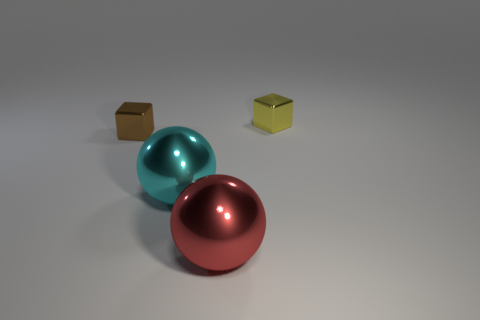Is there any other thing that is the same size as the cyan shiny thing?
Ensure brevity in your answer.  Yes. Is the small yellow shiny object the same shape as the brown shiny thing?
Offer a very short reply. Yes. There is a block left of the metal block that is to the right of the red shiny ball; what is its size?
Provide a short and direct response. Small. What color is the other shiny object that is the same shape as the brown thing?
Offer a very short reply. Yellow. The brown block has what size?
Your answer should be very brief. Small. Is the yellow object the same size as the brown cube?
Provide a short and direct response. Yes. What is the color of the metal object that is both to the right of the large cyan shiny thing and on the left side of the small yellow metallic cube?
Provide a succinct answer. Red. What number of other brown cubes have the same material as the small brown cube?
Ensure brevity in your answer.  0. What number of red shiny objects are there?
Your response must be concise. 1. There is a red metal thing; is it the same size as the block behind the small brown thing?
Provide a succinct answer. No. 